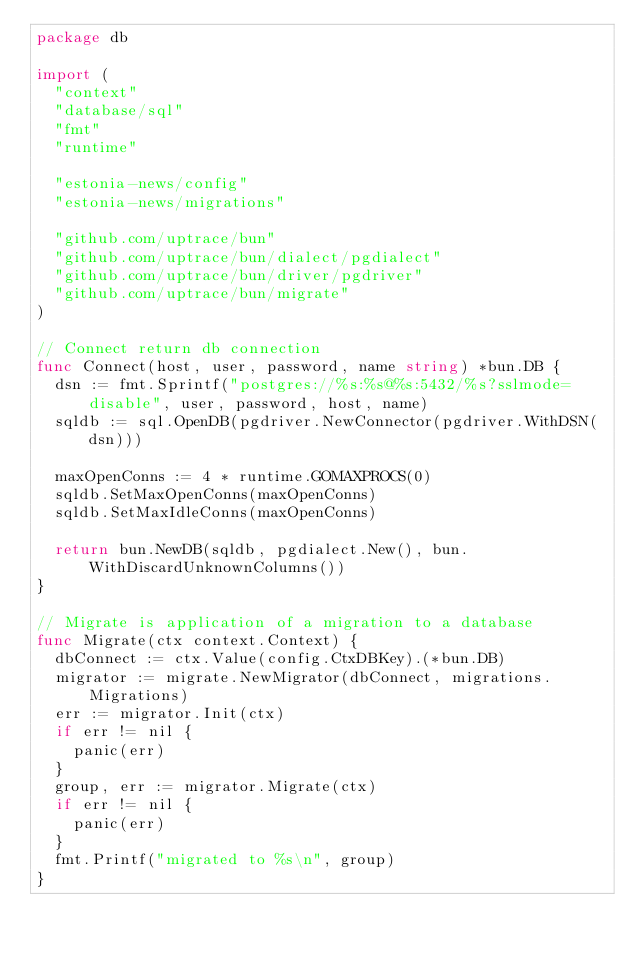Convert code to text. <code><loc_0><loc_0><loc_500><loc_500><_Go_>package db

import (
	"context"
	"database/sql"
	"fmt"
	"runtime"

	"estonia-news/config"
	"estonia-news/migrations"

	"github.com/uptrace/bun"
	"github.com/uptrace/bun/dialect/pgdialect"
	"github.com/uptrace/bun/driver/pgdriver"
	"github.com/uptrace/bun/migrate"
)

// Connect return db connection
func Connect(host, user, password, name string) *bun.DB {
	dsn := fmt.Sprintf("postgres://%s:%s@%s:5432/%s?sslmode=disable", user, password, host, name)
	sqldb := sql.OpenDB(pgdriver.NewConnector(pgdriver.WithDSN(dsn)))

	maxOpenConns := 4 * runtime.GOMAXPROCS(0)
	sqldb.SetMaxOpenConns(maxOpenConns)
	sqldb.SetMaxIdleConns(maxOpenConns)

	return bun.NewDB(sqldb, pgdialect.New(), bun.WithDiscardUnknownColumns())
}

// Migrate is application of a migration to a database
func Migrate(ctx context.Context) {
	dbConnect := ctx.Value(config.CtxDBKey).(*bun.DB)
	migrator := migrate.NewMigrator(dbConnect, migrations.Migrations)
	err := migrator.Init(ctx)
	if err != nil {
		panic(err)
	}
	group, err := migrator.Migrate(ctx)
	if err != nil {
		panic(err)
	}
	fmt.Printf("migrated to %s\n", group)
}
</code> 